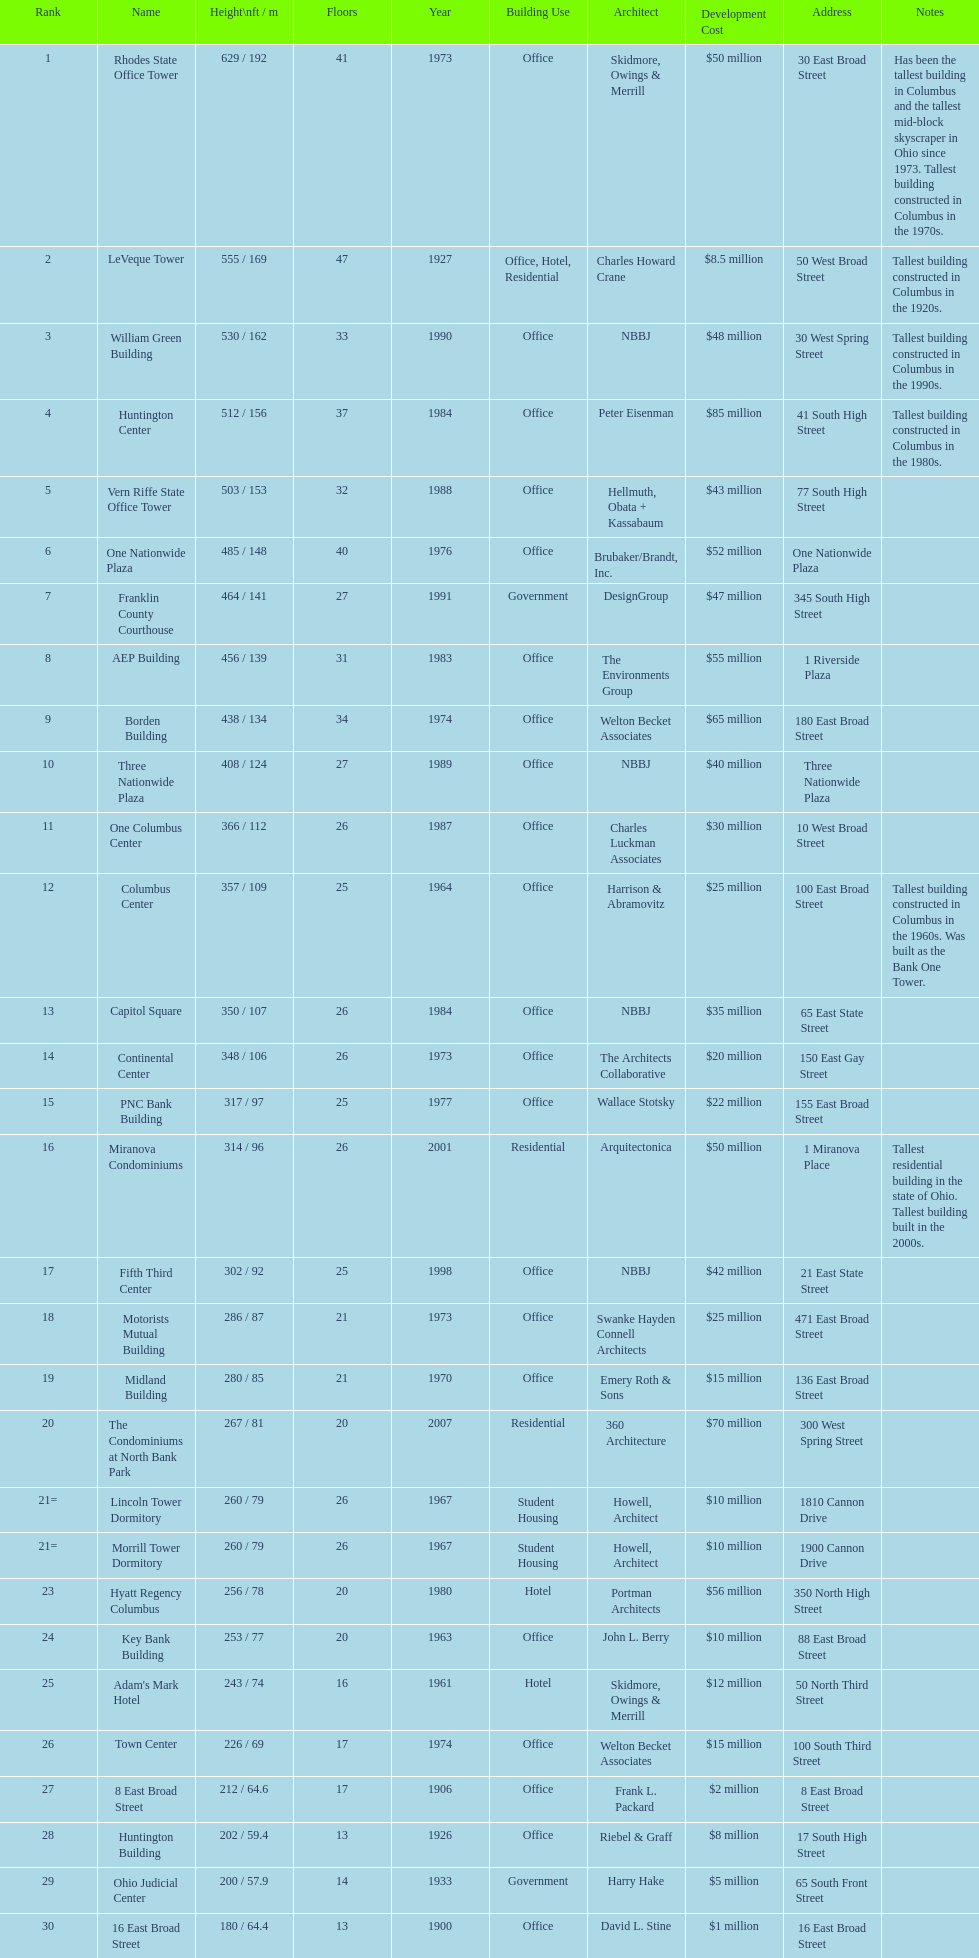Which is the tallest building? Rhodes State Office Tower. 